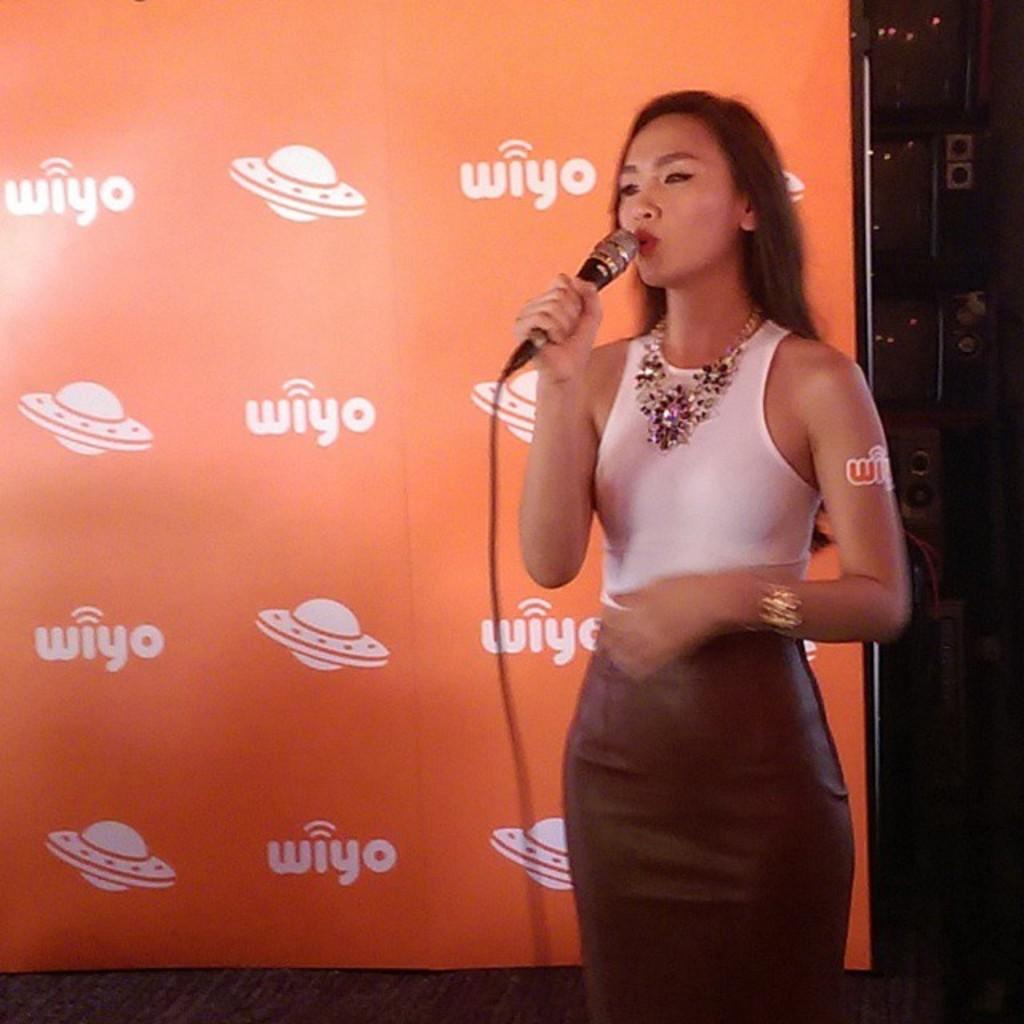Who is present in the image? There is a woman in the image. What is the woman holding in the image? The woman is holding a mic. What can be seen in the background of the image? There is a banner in the background of the image. What type of feast is being prepared in the image? There is no indication of a feast being prepared in the image; it features a woman holding a mic. Is there a drain visible in the image? There is no drain present in the image. 